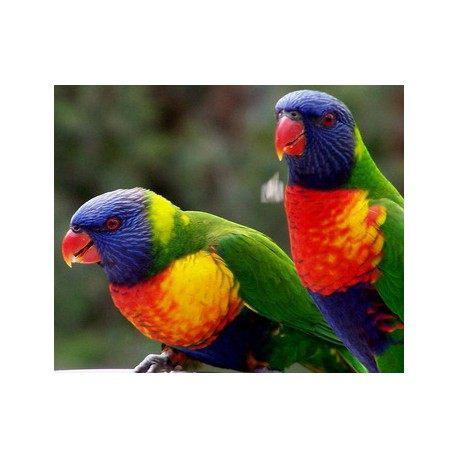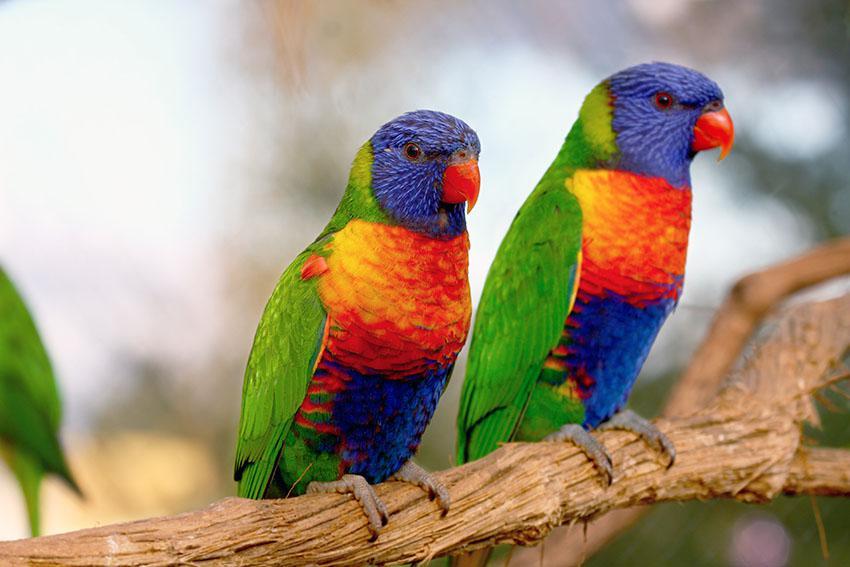The first image is the image on the left, the second image is the image on the right. Assess this claim about the two images: "An image contains only one left-facing parrot perched on some object.". Correct or not? Answer yes or no. No. The first image is the image on the left, the second image is the image on the right. Evaluate the accuracy of this statement regarding the images: "There are no more than 3 birds.". Is it true? Answer yes or no. No. 